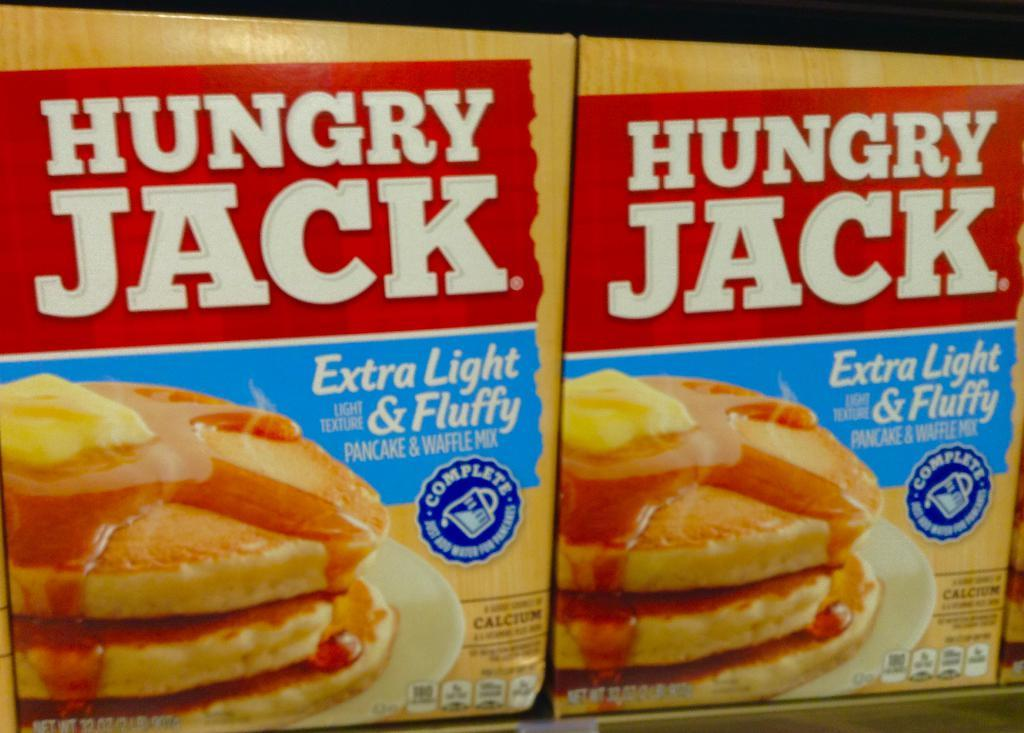How many packets are visible in the image? There are two packets in the image. What can be found on the surface of the packets? There is text and a logo on the packets. What type of volcano is depicted on the packets in the image? There is no volcano depicted on the packets in the image. Who is the manager of the packets in the image? The image does not provide information about a manager for the packets. Are there any servants visible in the image? There is no reference to servants in the image. 